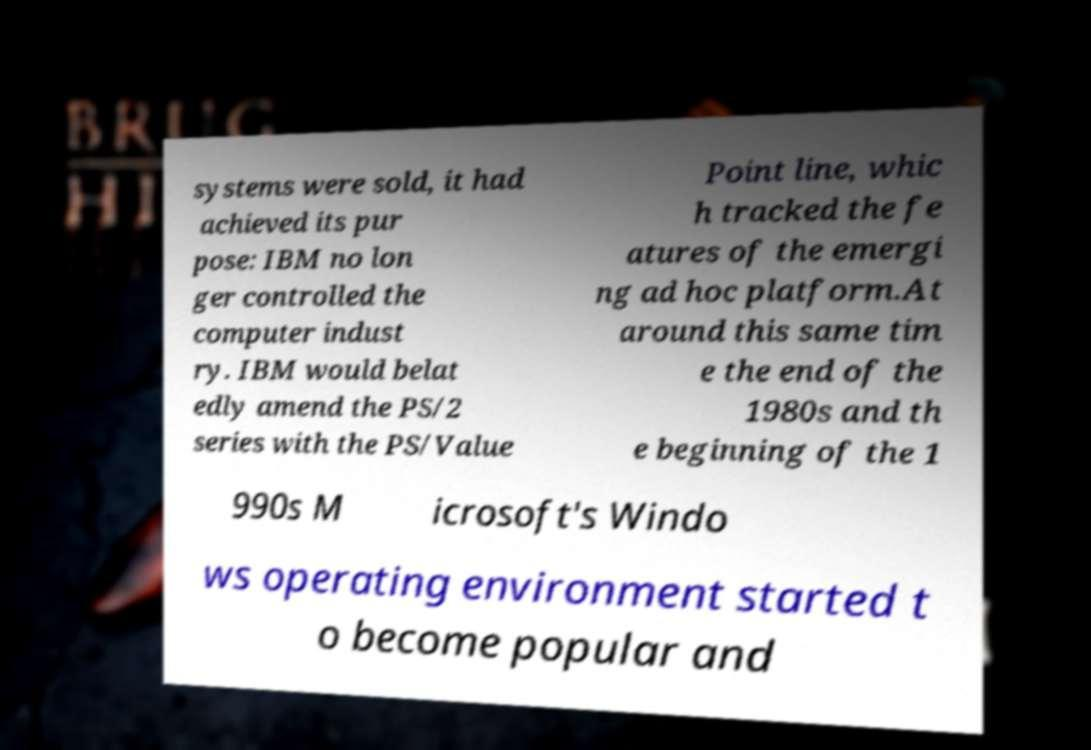There's text embedded in this image that I need extracted. Can you transcribe it verbatim? systems were sold, it had achieved its pur pose: IBM no lon ger controlled the computer indust ry. IBM would belat edly amend the PS/2 series with the PS/Value Point line, whic h tracked the fe atures of the emergi ng ad hoc platform.At around this same tim e the end of the 1980s and th e beginning of the 1 990s M icrosoft's Windo ws operating environment started t o become popular and 